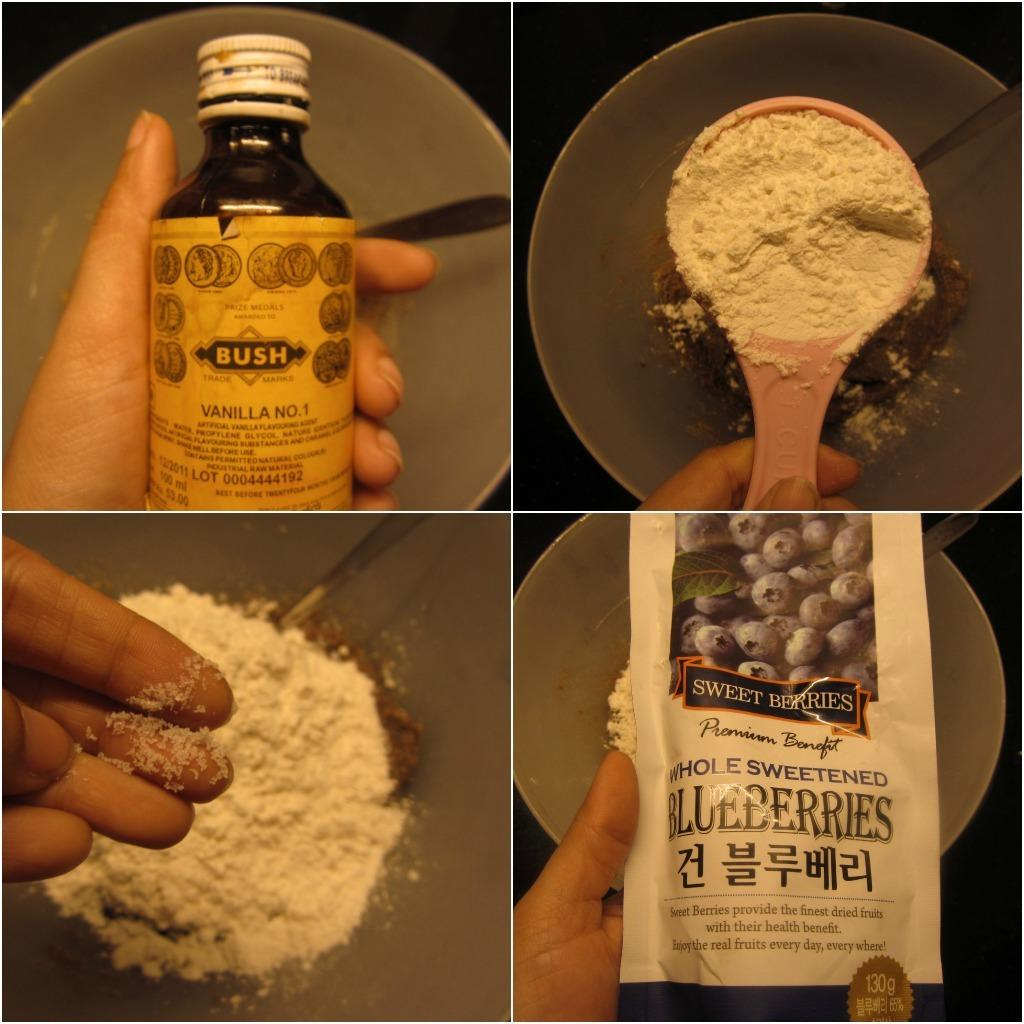<image>
Create a compact narrative representing the image presented. four panels showing a person making a recipe adding ingredients like Blueberries 